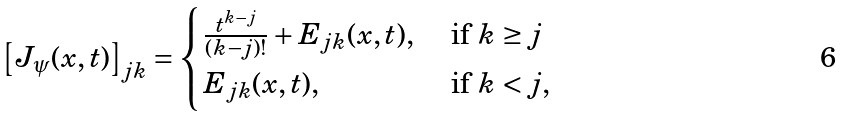<formula> <loc_0><loc_0><loc_500><loc_500>\left [ J _ { \psi } ( x , t ) \right ] _ { j k } = \begin{cases} \frac { t ^ { k - j } } { ( k - j ) ! } + E _ { j k } ( x , t ) , \ & \text {if } k \geq j \\ E _ { j k } ( x , t ) , \ & \text {if } k < j , \end{cases}</formula> 